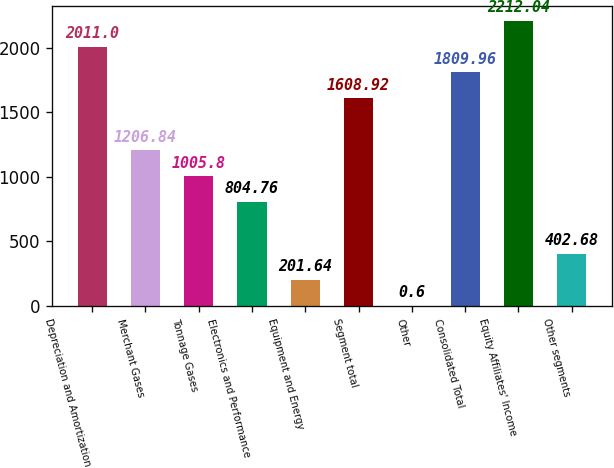Convert chart. <chart><loc_0><loc_0><loc_500><loc_500><bar_chart><fcel>Depreciation and Amortization<fcel>Merchant Gases<fcel>Tonnage Gases<fcel>Electronics and Performance<fcel>Equipment and Energy<fcel>Segment total<fcel>Other<fcel>Consolidated Total<fcel>Equity Affiliates' Income<fcel>Other segments<nl><fcel>2011<fcel>1206.84<fcel>1005.8<fcel>804.76<fcel>201.64<fcel>1608.92<fcel>0.6<fcel>1809.96<fcel>2212.04<fcel>402.68<nl></chart> 